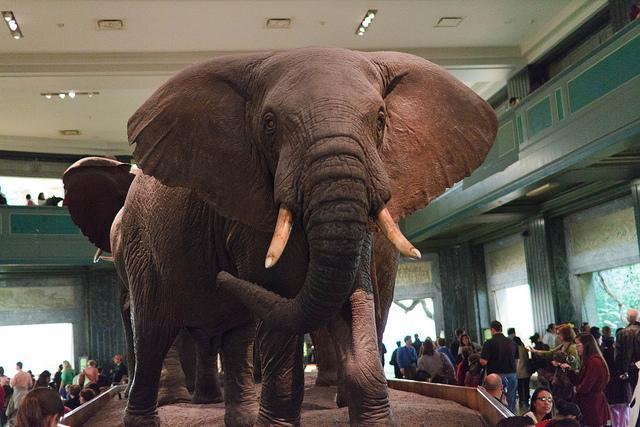How many people can you see?
Give a very brief answer. 2. How many elephants are in the picture?
Give a very brief answer. 2. How many giraffes are standing?
Give a very brief answer. 0. 